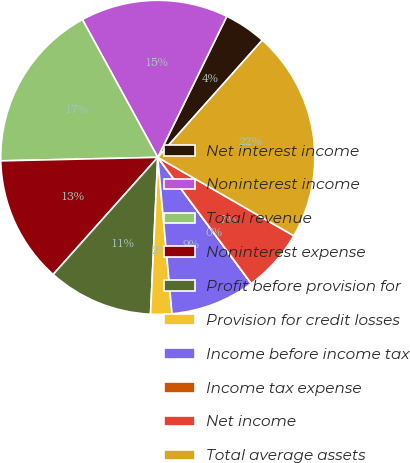<chart> <loc_0><loc_0><loc_500><loc_500><pie_chart><fcel>Net interest income<fcel>Noninterest income<fcel>Total revenue<fcel>Noninterest expense<fcel>Profit before provision for<fcel>Provision for credit losses<fcel>Income before income tax<fcel>Income tax expense<fcel>Net income<fcel>Total average assets<nl><fcel>4.35%<fcel>15.21%<fcel>17.39%<fcel>13.04%<fcel>10.87%<fcel>2.18%<fcel>8.7%<fcel>0.01%<fcel>6.52%<fcel>21.73%<nl></chart> 